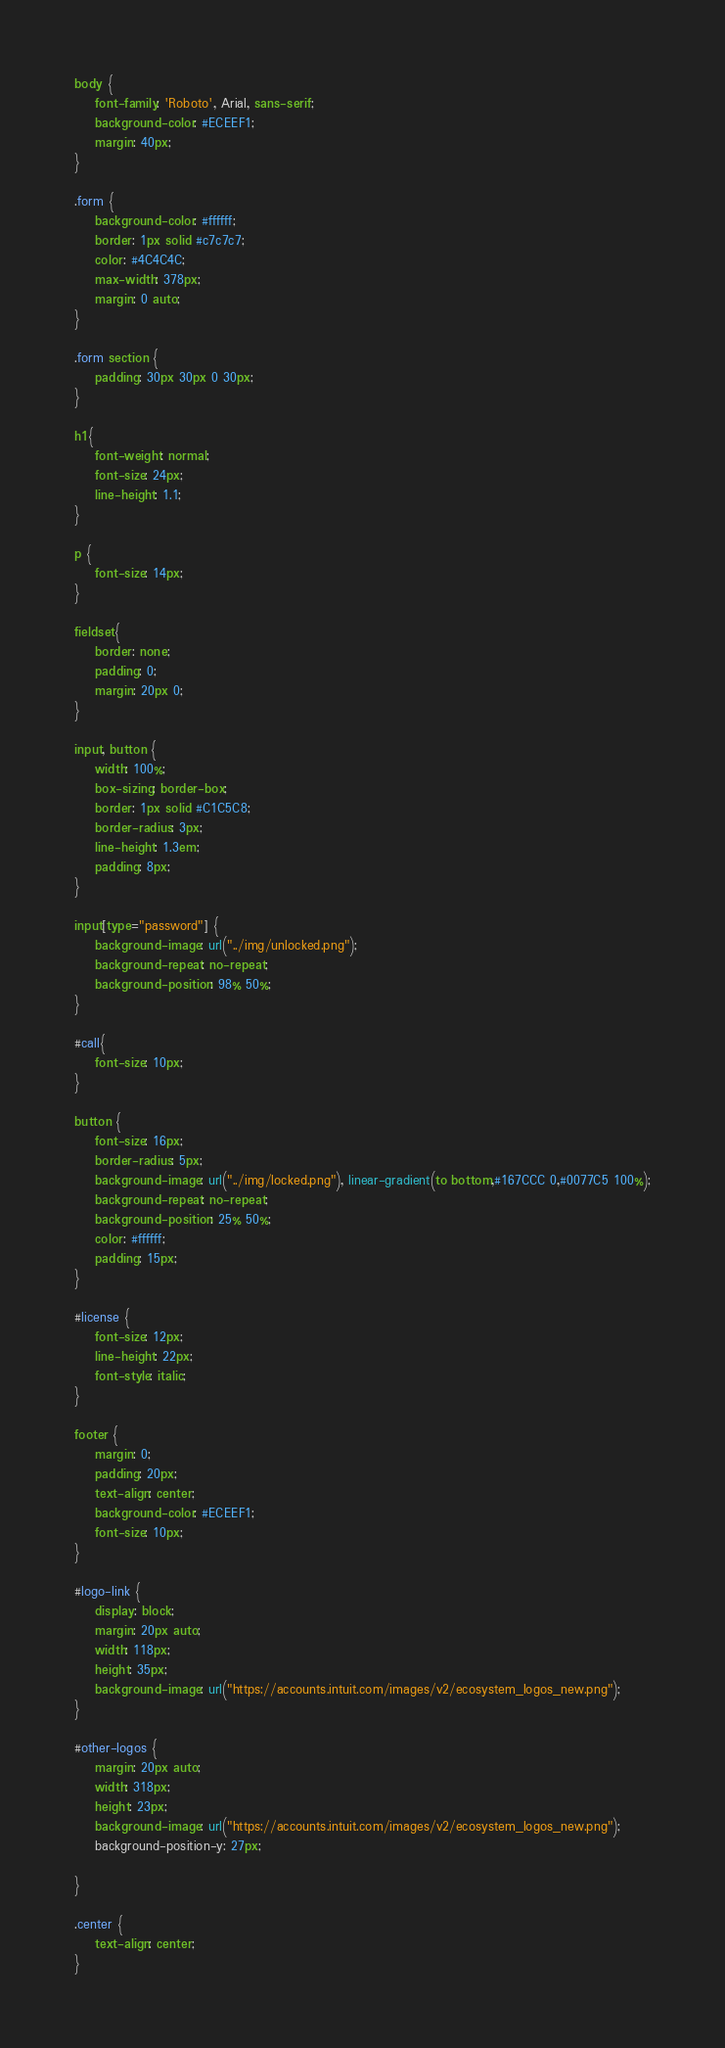<code> <loc_0><loc_0><loc_500><loc_500><_CSS_>body {
    font-family: 'Roboto', Arial, sans-serif;
    background-color: #ECEEF1;
    margin: 40px;
}

.form {
    background-color: #ffffff;
    border: 1px solid #c7c7c7;
    color: #4C4C4C;
    max-width: 378px;
    margin: 0 auto;
}

.form section {
    padding: 30px 30px 0 30px;
}

h1{
    font-weight: normal;
    font-size: 24px;
    line-height: 1.1;
}

p {
    font-size: 14px;
}

fieldset{
    border: none;
    padding: 0;
    margin: 20px 0;
}

input, button {
    width: 100%;
    box-sizing: border-box;
    border: 1px solid #C1C5C8;
    border-radius: 3px;
    line-height: 1.3em;
    padding: 8px;
}

input[type="password"] {
    background-image: url("../img/unlocked.png");
    background-repeat: no-repeat;
    background-position: 98% 50%;
}

#call{
    font-size: 10px;
}

button {
    font-size: 16px;
    border-radius: 5px;
    background-image: url("../img/locked.png"), linear-gradient(to bottom,#167CCC 0,#0077C5 100%);
    background-repeat: no-repeat;
    background-position: 25% 50%;
    color: #ffffff;
    padding: 15px;
}

#license {
    font-size: 12px;
    line-height: 22px;
    font-style: italic;
}

footer {
    margin: 0;
    padding: 20px;
    text-align: center;
    background-color: #ECEEF1;
    font-size: 10px;
}

#logo-link {
    display: block;
    margin: 20px auto;
    width: 118px;
    height: 35px;
    background-image: url("https://accounts.intuit.com/images/v2/ecosystem_logos_new.png");
}

#other-logos {
    margin: 20px auto;
    width: 318px;
    height: 23px;
    background-image: url("https://accounts.intuit.com/images/v2/ecosystem_logos_new.png");
    background-position-y: 27px;

}

.center {
    text-align: center;
}</code> 